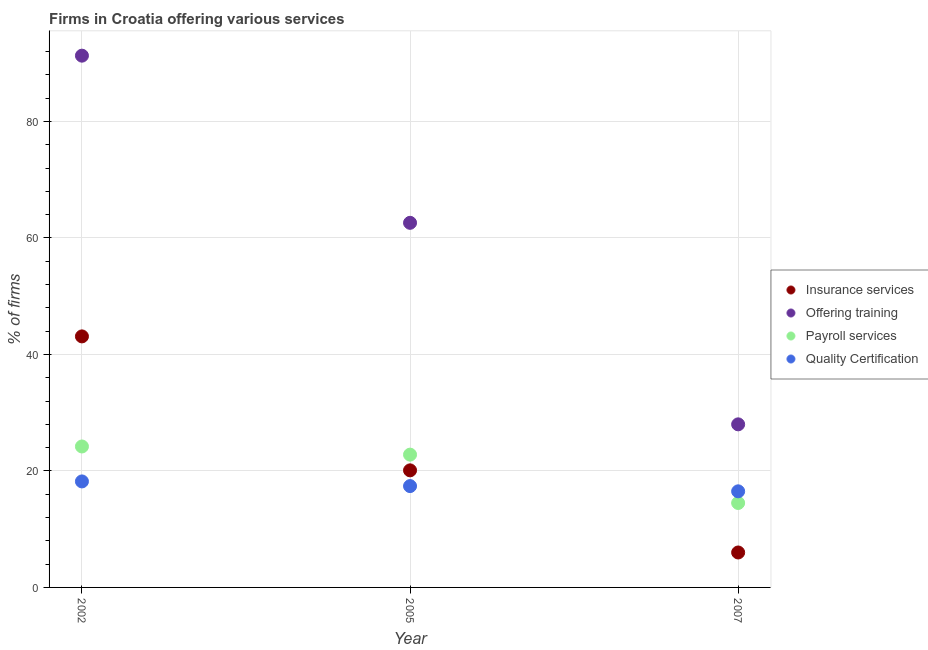How many different coloured dotlines are there?
Ensure brevity in your answer.  4. Is the number of dotlines equal to the number of legend labels?
Your response must be concise. Yes. What is the percentage of firms offering insurance services in 2007?
Keep it short and to the point. 6. Across all years, what is the maximum percentage of firms offering payroll services?
Your response must be concise. 24.2. In which year was the percentage of firms offering payroll services maximum?
Give a very brief answer. 2002. In which year was the percentage of firms offering quality certification minimum?
Provide a succinct answer. 2007. What is the total percentage of firms offering insurance services in the graph?
Ensure brevity in your answer.  69.2. What is the difference between the percentage of firms offering payroll services in 2002 and that in 2007?
Provide a succinct answer. 9.7. What is the difference between the percentage of firms offering quality certification in 2007 and the percentage of firms offering insurance services in 2005?
Your response must be concise. -3.6. What is the average percentage of firms offering training per year?
Your response must be concise. 60.63. In the year 2002, what is the difference between the percentage of firms offering payroll services and percentage of firms offering insurance services?
Your response must be concise. -18.9. In how many years, is the percentage of firms offering payroll services greater than 24 %?
Ensure brevity in your answer.  1. What is the ratio of the percentage of firms offering insurance services in 2002 to that in 2007?
Provide a succinct answer. 7.18. Is the percentage of firms offering insurance services in 2005 less than that in 2007?
Give a very brief answer. No. Is the difference between the percentage of firms offering quality certification in 2005 and 2007 greater than the difference between the percentage of firms offering insurance services in 2005 and 2007?
Your answer should be very brief. No. What is the difference between the highest and the second highest percentage of firms offering quality certification?
Keep it short and to the point. 0.8. What is the difference between the highest and the lowest percentage of firms offering insurance services?
Your response must be concise. 37.1. In how many years, is the percentage of firms offering insurance services greater than the average percentage of firms offering insurance services taken over all years?
Your response must be concise. 1. Is it the case that in every year, the sum of the percentage of firms offering insurance services and percentage of firms offering payroll services is greater than the sum of percentage of firms offering quality certification and percentage of firms offering training?
Ensure brevity in your answer.  No. Does the percentage of firms offering payroll services monotonically increase over the years?
Your response must be concise. No. Is the percentage of firms offering quality certification strictly greater than the percentage of firms offering training over the years?
Offer a terse response. No. How many dotlines are there?
Give a very brief answer. 4. How many years are there in the graph?
Keep it short and to the point. 3. What is the difference between two consecutive major ticks on the Y-axis?
Your answer should be very brief. 20. Does the graph contain any zero values?
Make the answer very short. No. Does the graph contain grids?
Make the answer very short. Yes. Where does the legend appear in the graph?
Provide a succinct answer. Center right. How many legend labels are there?
Provide a succinct answer. 4. What is the title of the graph?
Give a very brief answer. Firms in Croatia offering various services . Does "CO2 damage" appear as one of the legend labels in the graph?
Your response must be concise. No. What is the label or title of the X-axis?
Keep it short and to the point. Year. What is the label or title of the Y-axis?
Offer a terse response. % of firms. What is the % of firms of Insurance services in 2002?
Offer a terse response. 43.1. What is the % of firms of Offering training in 2002?
Ensure brevity in your answer.  91.3. What is the % of firms in Payroll services in 2002?
Provide a short and direct response. 24.2. What is the % of firms of Insurance services in 2005?
Give a very brief answer. 20.1. What is the % of firms in Offering training in 2005?
Your response must be concise. 62.6. What is the % of firms of Payroll services in 2005?
Provide a short and direct response. 22.8. What is the % of firms in Insurance services in 2007?
Keep it short and to the point. 6. What is the % of firms of Offering training in 2007?
Your response must be concise. 28. What is the % of firms of Payroll services in 2007?
Ensure brevity in your answer.  14.5. What is the % of firms of Quality Certification in 2007?
Your answer should be very brief. 16.5. Across all years, what is the maximum % of firms of Insurance services?
Your response must be concise. 43.1. Across all years, what is the maximum % of firms in Offering training?
Provide a succinct answer. 91.3. Across all years, what is the maximum % of firms in Payroll services?
Make the answer very short. 24.2. Across all years, what is the minimum % of firms in Insurance services?
Your response must be concise. 6. Across all years, what is the minimum % of firms of Quality Certification?
Provide a succinct answer. 16.5. What is the total % of firms of Insurance services in the graph?
Make the answer very short. 69.2. What is the total % of firms of Offering training in the graph?
Keep it short and to the point. 181.9. What is the total % of firms of Payroll services in the graph?
Give a very brief answer. 61.5. What is the total % of firms in Quality Certification in the graph?
Make the answer very short. 52.1. What is the difference between the % of firms in Offering training in 2002 and that in 2005?
Provide a succinct answer. 28.7. What is the difference between the % of firms of Insurance services in 2002 and that in 2007?
Your response must be concise. 37.1. What is the difference between the % of firms in Offering training in 2002 and that in 2007?
Keep it short and to the point. 63.3. What is the difference between the % of firms in Insurance services in 2005 and that in 2007?
Offer a very short reply. 14.1. What is the difference between the % of firms of Offering training in 2005 and that in 2007?
Offer a very short reply. 34.6. What is the difference between the % of firms of Insurance services in 2002 and the % of firms of Offering training in 2005?
Your response must be concise. -19.5. What is the difference between the % of firms in Insurance services in 2002 and the % of firms in Payroll services in 2005?
Keep it short and to the point. 20.3. What is the difference between the % of firms in Insurance services in 2002 and the % of firms in Quality Certification in 2005?
Your answer should be compact. 25.7. What is the difference between the % of firms of Offering training in 2002 and the % of firms of Payroll services in 2005?
Provide a short and direct response. 68.5. What is the difference between the % of firms in Offering training in 2002 and the % of firms in Quality Certification in 2005?
Provide a succinct answer. 73.9. What is the difference between the % of firms of Insurance services in 2002 and the % of firms of Offering training in 2007?
Keep it short and to the point. 15.1. What is the difference between the % of firms of Insurance services in 2002 and the % of firms of Payroll services in 2007?
Ensure brevity in your answer.  28.6. What is the difference between the % of firms in Insurance services in 2002 and the % of firms in Quality Certification in 2007?
Keep it short and to the point. 26.6. What is the difference between the % of firms of Offering training in 2002 and the % of firms of Payroll services in 2007?
Provide a short and direct response. 76.8. What is the difference between the % of firms of Offering training in 2002 and the % of firms of Quality Certification in 2007?
Your answer should be very brief. 74.8. What is the difference between the % of firms of Insurance services in 2005 and the % of firms of Offering training in 2007?
Give a very brief answer. -7.9. What is the difference between the % of firms in Insurance services in 2005 and the % of firms in Quality Certification in 2007?
Ensure brevity in your answer.  3.6. What is the difference between the % of firms of Offering training in 2005 and the % of firms of Payroll services in 2007?
Provide a succinct answer. 48.1. What is the difference between the % of firms in Offering training in 2005 and the % of firms in Quality Certification in 2007?
Offer a very short reply. 46.1. What is the average % of firms in Insurance services per year?
Your response must be concise. 23.07. What is the average % of firms of Offering training per year?
Provide a succinct answer. 60.63. What is the average % of firms of Quality Certification per year?
Offer a very short reply. 17.37. In the year 2002, what is the difference between the % of firms in Insurance services and % of firms in Offering training?
Provide a succinct answer. -48.2. In the year 2002, what is the difference between the % of firms of Insurance services and % of firms of Payroll services?
Make the answer very short. 18.9. In the year 2002, what is the difference between the % of firms in Insurance services and % of firms in Quality Certification?
Give a very brief answer. 24.9. In the year 2002, what is the difference between the % of firms in Offering training and % of firms in Payroll services?
Give a very brief answer. 67.1. In the year 2002, what is the difference between the % of firms in Offering training and % of firms in Quality Certification?
Your answer should be compact. 73.1. In the year 2005, what is the difference between the % of firms in Insurance services and % of firms in Offering training?
Provide a short and direct response. -42.5. In the year 2005, what is the difference between the % of firms of Insurance services and % of firms of Payroll services?
Offer a terse response. -2.7. In the year 2005, what is the difference between the % of firms in Insurance services and % of firms in Quality Certification?
Provide a succinct answer. 2.7. In the year 2005, what is the difference between the % of firms of Offering training and % of firms of Payroll services?
Your answer should be very brief. 39.8. In the year 2005, what is the difference between the % of firms in Offering training and % of firms in Quality Certification?
Your response must be concise. 45.2. In the year 2007, what is the difference between the % of firms of Insurance services and % of firms of Offering training?
Provide a succinct answer. -22. In the year 2007, what is the difference between the % of firms in Insurance services and % of firms in Payroll services?
Your response must be concise. -8.5. In the year 2007, what is the difference between the % of firms in Payroll services and % of firms in Quality Certification?
Offer a very short reply. -2. What is the ratio of the % of firms of Insurance services in 2002 to that in 2005?
Your answer should be compact. 2.14. What is the ratio of the % of firms of Offering training in 2002 to that in 2005?
Your response must be concise. 1.46. What is the ratio of the % of firms of Payroll services in 2002 to that in 2005?
Provide a short and direct response. 1.06. What is the ratio of the % of firms in Quality Certification in 2002 to that in 2005?
Ensure brevity in your answer.  1.05. What is the ratio of the % of firms in Insurance services in 2002 to that in 2007?
Your response must be concise. 7.18. What is the ratio of the % of firms in Offering training in 2002 to that in 2007?
Provide a succinct answer. 3.26. What is the ratio of the % of firms in Payroll services in 2002 to that in 2007?
Your answer should be very brief. 1.67. What is the ratio of the % of firms in Quality Certification in 2002 to that in 2007?
Provide a succinct answer. 1.1. What is the ratio of the % of firms in Insurance services in 2005 to that in 2007?
Provide a succinct answer. 3.35. What is the ratio of the % of firms in Offering training in 2005 to that in 2007?
Provide a succinct answer. 2.24. What is the ratio of the % of firms of Payroll services in 2005 to that in 2007?
Make the answer very short. 1.57. What is the ratio of the % of firms in Quality Certification in 2005 to that in 2007?
Give a very brief answer. 1.05. What is the difference between the highest and the second highest % of firms of Insurance services?
Give a very brief answer. 23. What is the difference between the highest and the second highest % of firms in Offering training?
Provide a succinct answer. 28.7. What is the difference between the highest and the second highest % of firms in Payroll services?
Offer a terse response. 1.4. What is the difference between the highest and the second highest % of firms of Quality Certification?
Provide a short and direct response. 0.8. What is the difference between the highest and the lowest % of firms of Insurance services?
Offer a terse response. 37.1. What is the difference between the highest and the lowest % of firms in Offering training?
Offer a very short reply. 63.3. What is the difference between the highest and the lowest % of firms in Payroll services?
Make the answer very short. 9.7. 